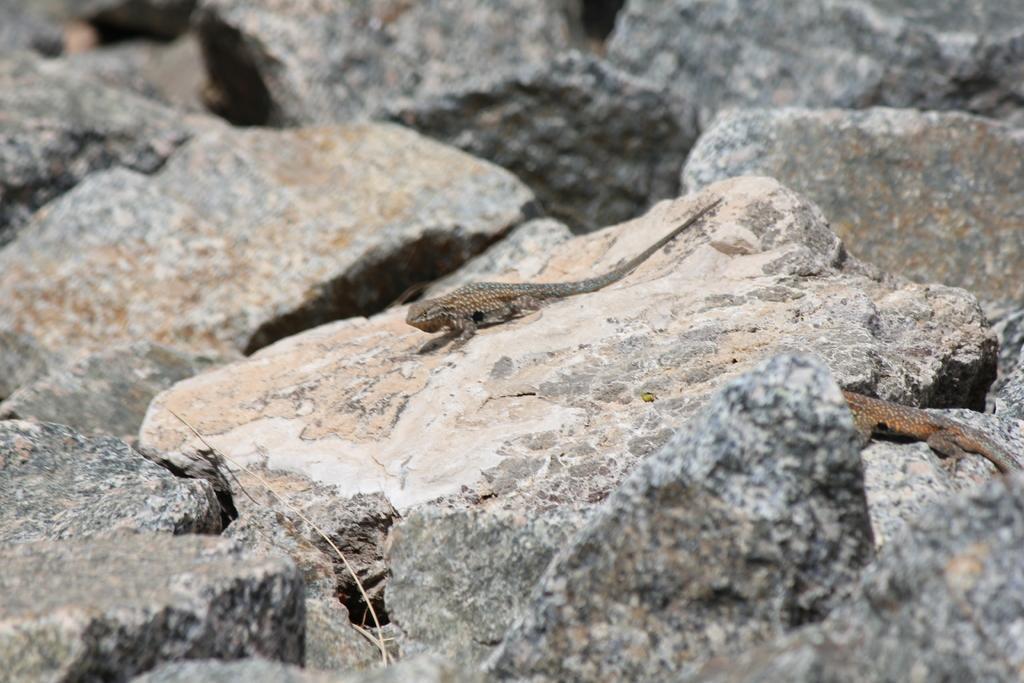Describe this image in one or two sentences. As we can see in the image there are rocks and two lizards. 